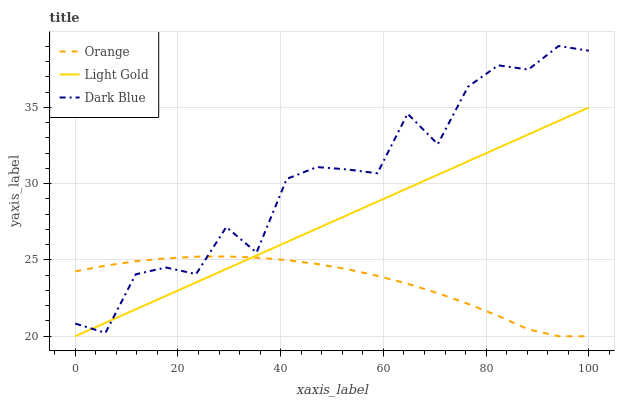Does Light Gold have the minimum area under the curve?
Answer yes or no. No. Does Light Gold have the maximum area under the curve?
Answer yes or no. No. Is Dark Blue the smoothest?
Answer yes or no. No. Is Light Gold the roughest?
Answer yes or no. No. Does Dark Blue have the lowest value?
Answer yes or no. No. Does Light Gold have the highest value?
Answer yes or no. No. 